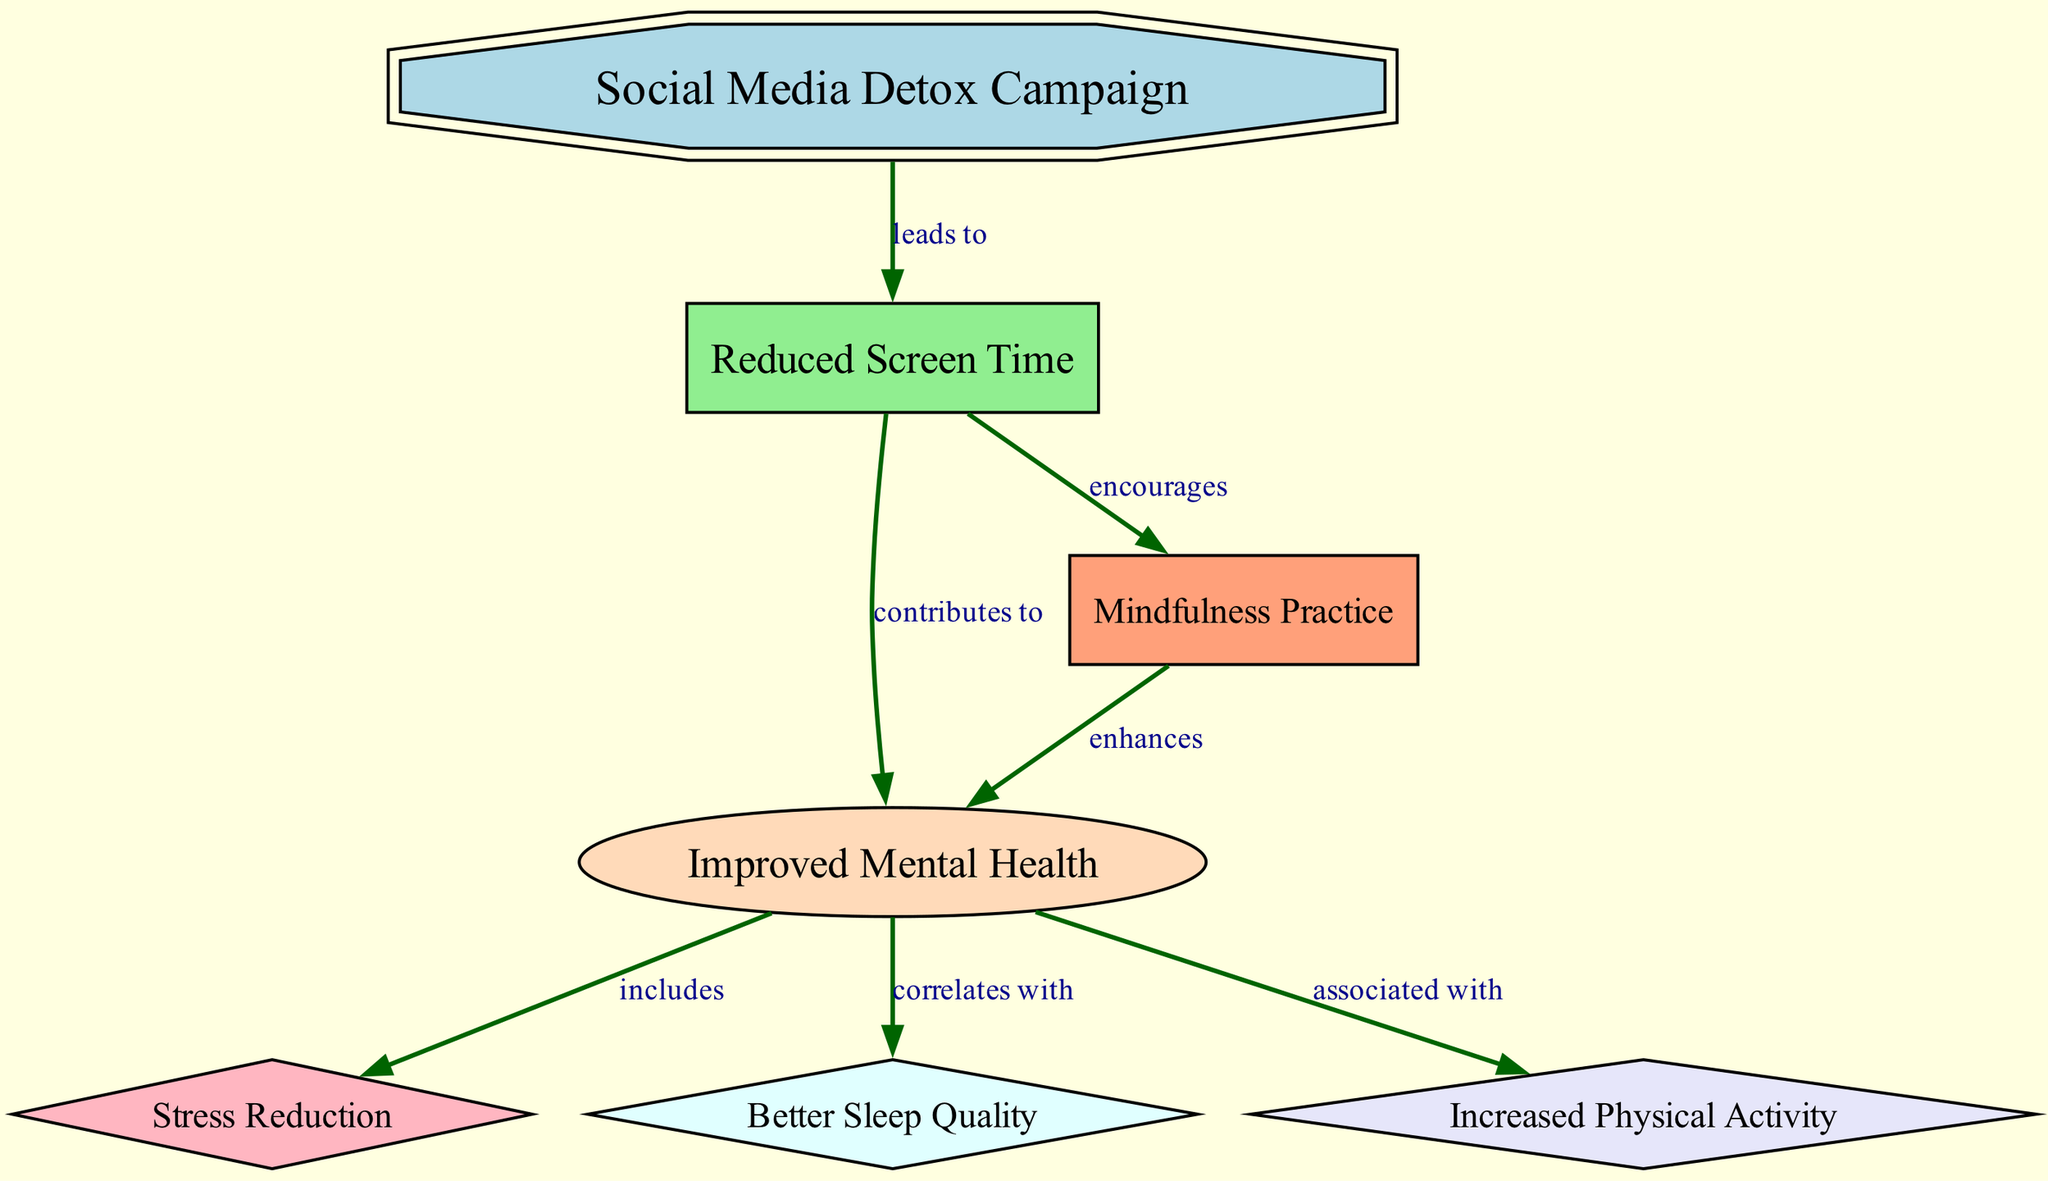What is the main focus of the diagram? The main focus of the diagram is the "Social Media Detox Campaign," which serves as the central node connecting to several outcomes.
Answer: Social Media Detox Campaign How many nodes are present in the diagram? By counting the entries under the "nodes" section in the data provided, there are a total of 7 nodes.
Answer: 7 What does "Reduced Screen Time" lead to? The diagram indicates that "Reduced Screen Time" leads to "Improved Mental Health," based on a direct relationship denoted by an edge.
Answer: Improved Mental Health Which node is associated with "Mindfulness Practice"? The diagram shows that "Mindfulness Practice" is encouraged by "Reduced Screen Time," indicating a positive relationship between these two nodes.
Answer: Reduced Screen Time What does "Improved Mental Health" correlate with? According to the diagram, "Improved Mental Health" correlates with "Better Sleep Quality," indicating a relationship based on shared benefits.
Answer: Better Sleep Quality Which node is related to "Stress Reduction"? The "Stress Reduction" node is included as an aspect of "Improved Mental Health," which points to its direct connection to overall mental well-being.
Answer: Improved Mental Health How many relationships does the "Social Media Detox Campaign" have? The "Social Media Detox Campaign" has one relationship leading to "Reduced Screen Time," which then links to further outcomes, counting as one initial relationship.
Answer: 1 How does "Mindfulness Practice" enhance mental health? The diagram illustrates that "Mindfulness Practice" enhances "Improved Mental Health," showing that the practice contributes positively to mental well-being.
Answer: Improved Mental Health What type of relationship exists between "Reduced Screen Time" and "Mindfulness Practice"? The relationship is described as "encourages," showing that less time on screens promotes engagement in mindfulness activities.
Answer: encourages 